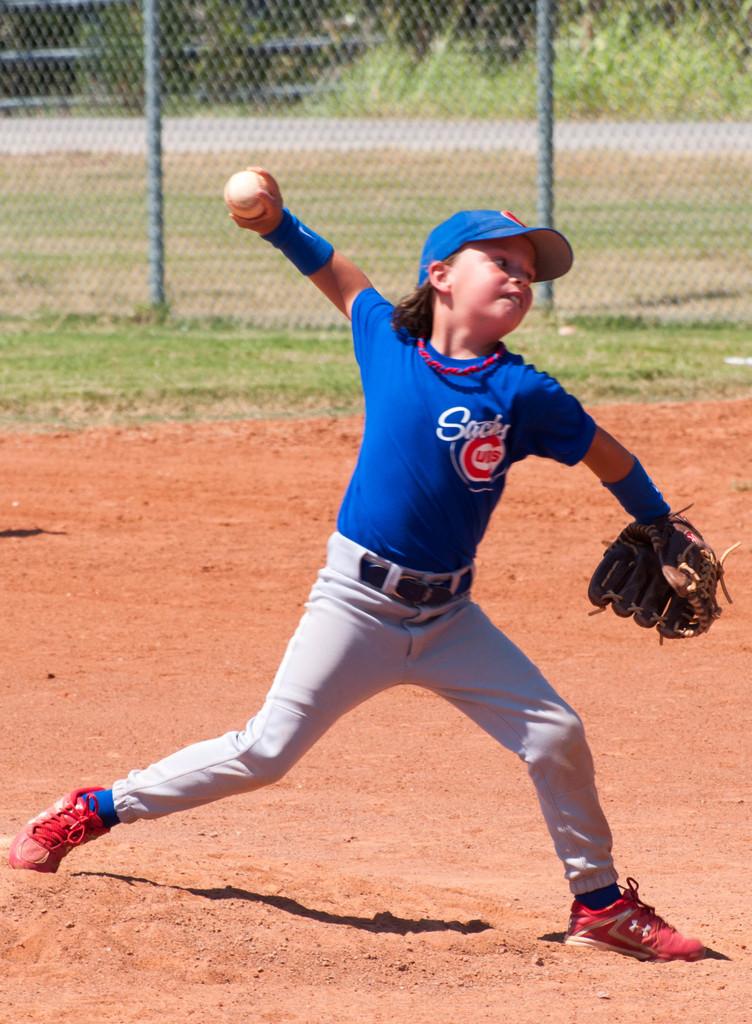What team does she play for?
Offer a very short reply. Cubs. 